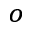<formula> <loc_0><loc_0><loc_500><loc_500>^ { o }</formula> 